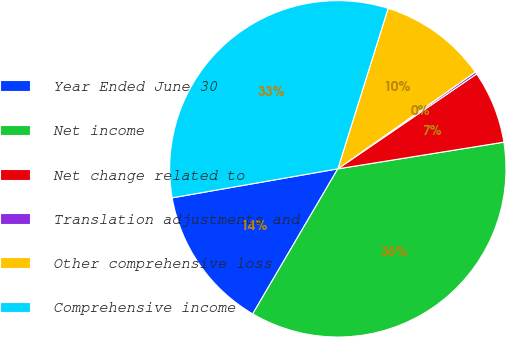Convert chart to OTSL. <chart><loc_0><loc_0><loc_500><loc_500><pie_chart><fcel>Year Ended June 30<fcel>Net income<fcel>Net change related to<fcel>Translation adjustments and<fcel>Other comprehensive loss<fcel>Comprehensive income<nl><fcel>13.8%<fcel>35.98%<fcel>7.01%<fcel>0.22%<fcel>10.4%<fcel>32.59%<nl></chart> 